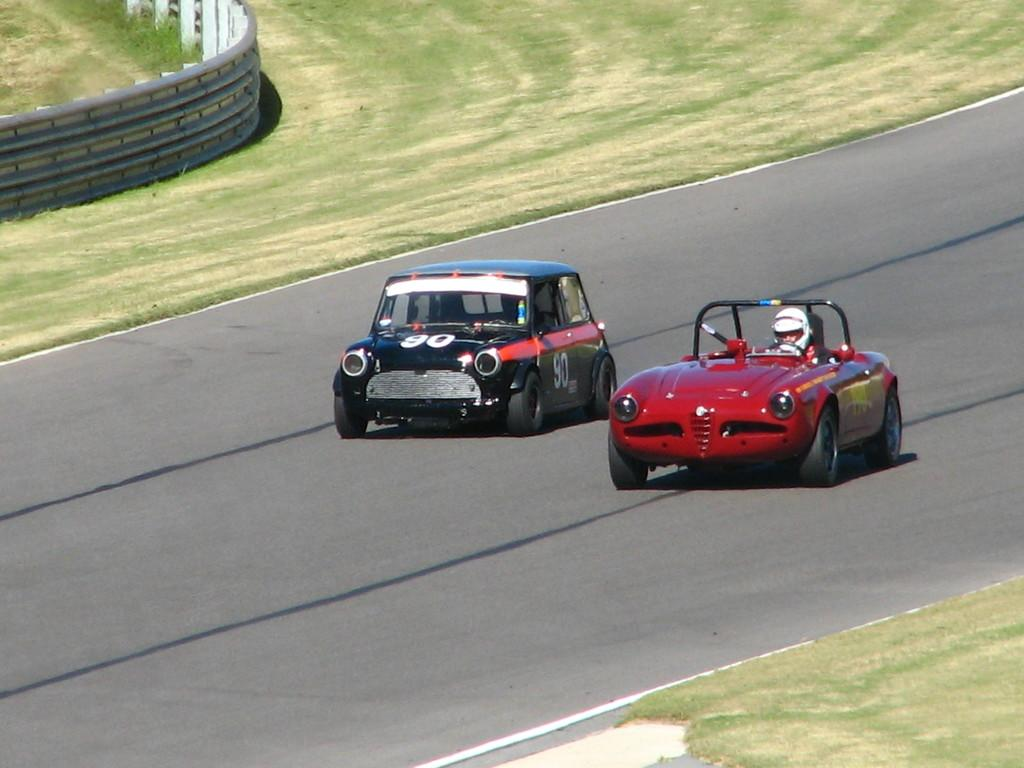How many cars are visible on the road in the image? There are two cars on the road in the image. What can be seen beside the road? There is grass and a fence beside the road. What type of appliance is being used to study history in the image? There is no appliance or history study present in the image; it features two cars on the road with grass and a fence beside it. 